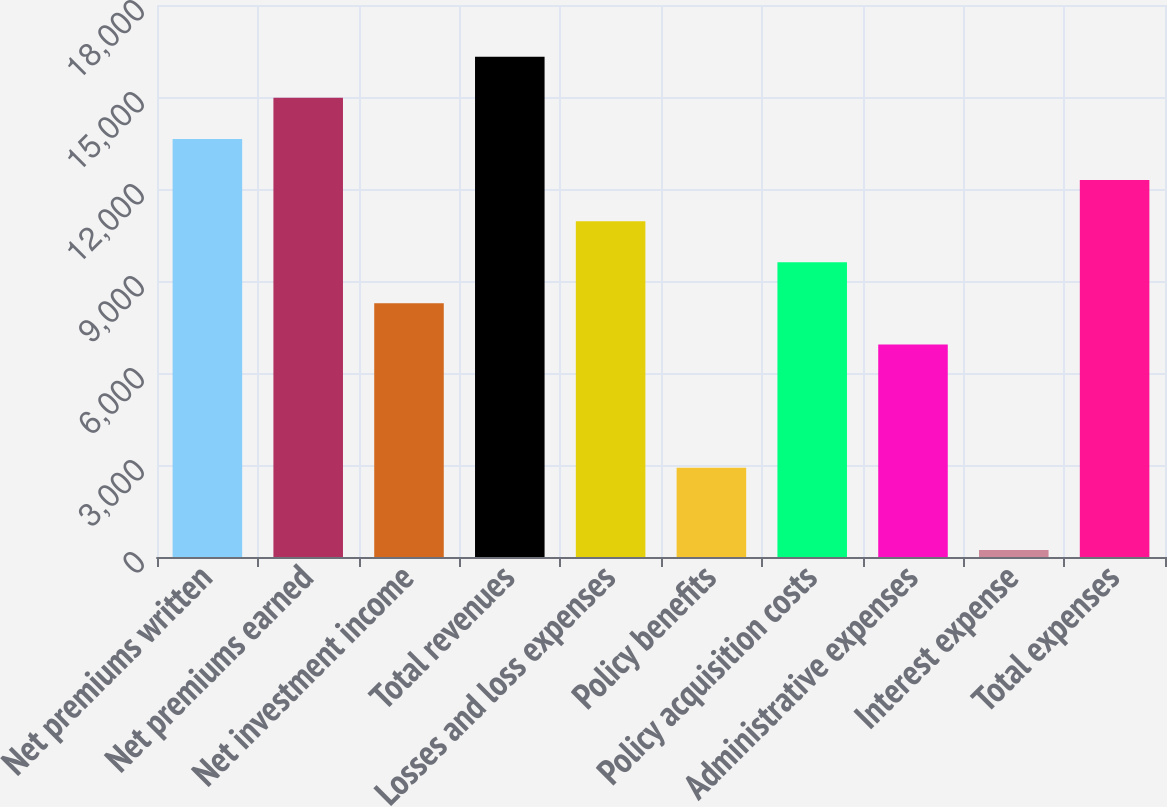Convert chart to OTSL. <chart><loc_0><loc_0><loc_500><loc_500><bar_chart><fcel>Net premiums written<fcel>Net premiums earned<fcel>Net investment income<fcel>Total revenues<fcel>Losses and loss expenses<fcel>Policy benefits<fcel>Policy acquisition costs<fcel>Administrative expenses<fcel>Interest expense<fcel>Total expenses<nl><fcel>13632<fcel>14972.2<fcel>8271.2<fcel>16312.4<fcel>10951.6<fcel>2910.4<fcel>9611.4<fcel>6931<fcel>230<fcel>12291.8<nl></chart> 